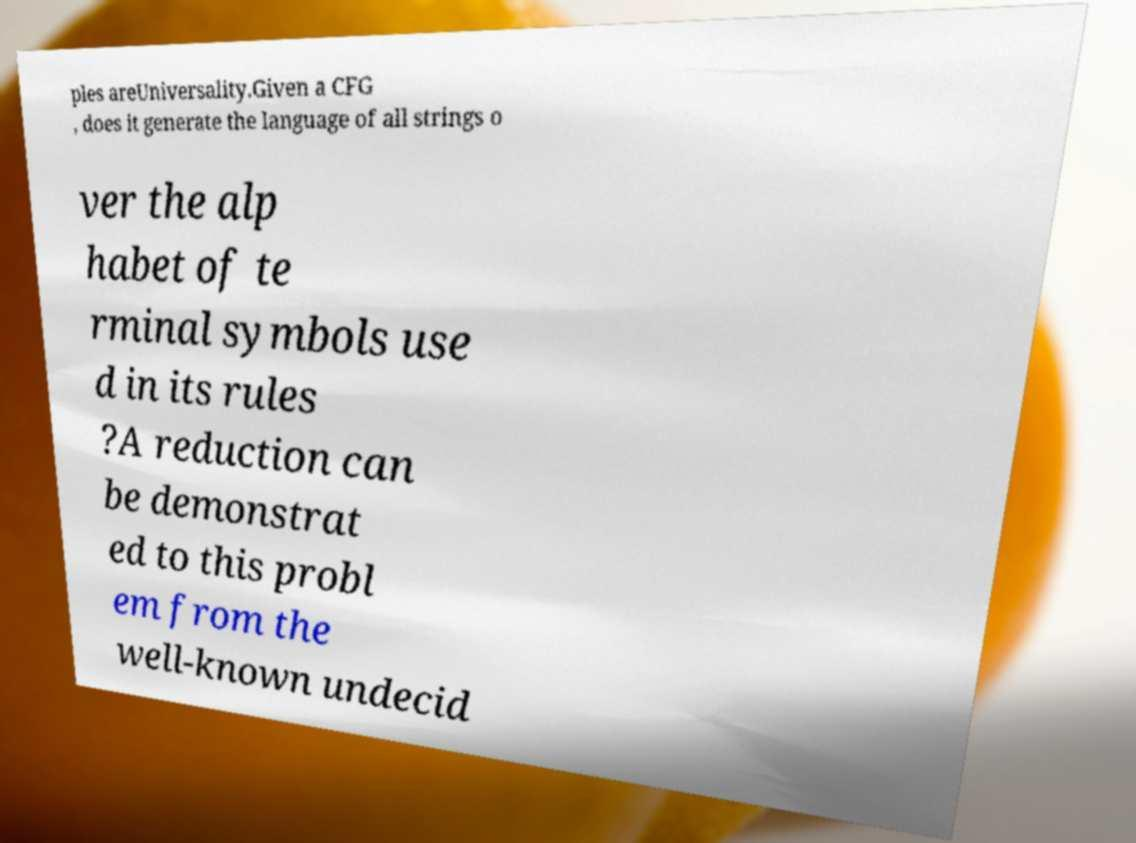Please identify and transcribe the text found in this image. ples areUniversality.Given a CFG , does it generate the language of all strings o ver the alp habet of te rminal symbols use d in its rules ?A reduction can be demonstrat ed to this probl em from the well-known undecid 